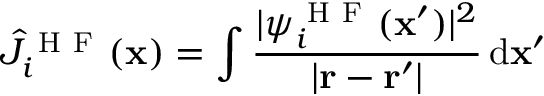Convert formula to latex. <formula><loc_0><loc_0><loc_500><loc_500>\hat { J } _ { i } ^ { H F } ( x ) = \int \frac { | \psi _ { i } ^ { H F } ( x ^ { \prime } ) | ^ { 2 } } { | r - r ^ { \prime } | } \, d x ^ { \prime }</formula> 